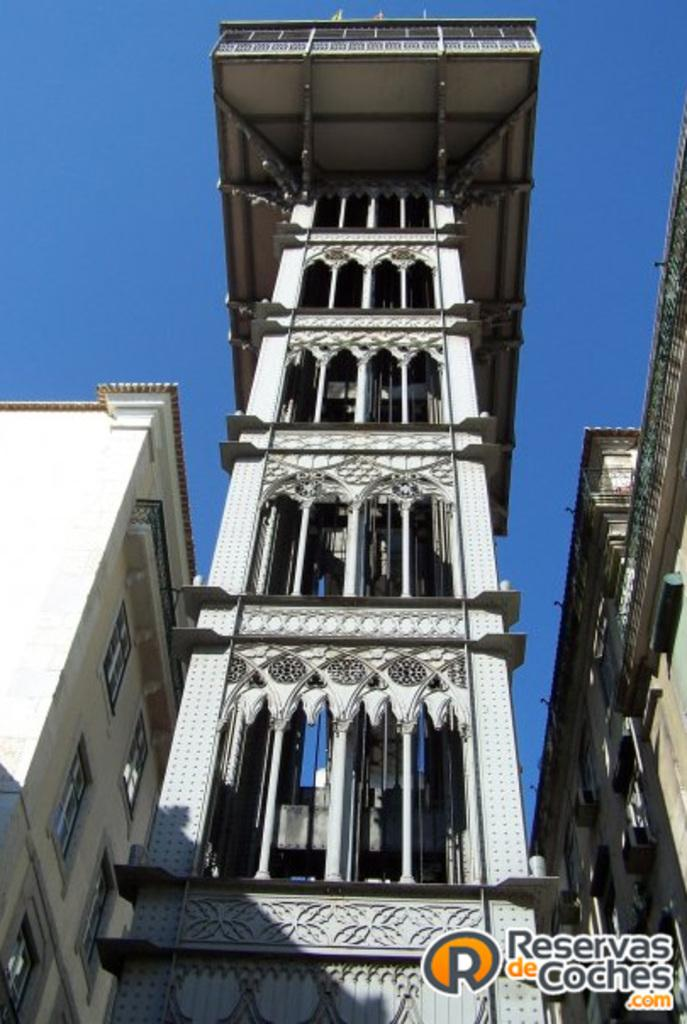What is the primary subject of the image? The primary subject of the image is many buildings. Can you describe any additional features of the image? There is a watermark at the bottom of the image. What type of voice can be heard coming from the buildings in the image? There is no voice present in the image, as it is a still image of buildings. 